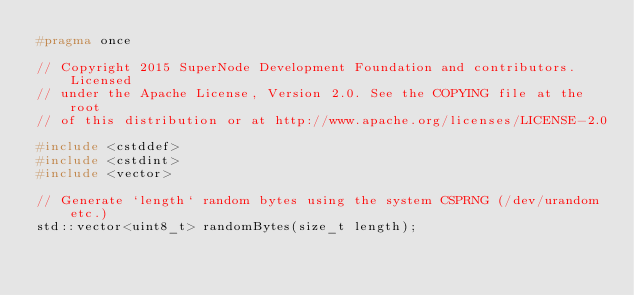<code> <loc_0><loc_0><loc_500><loc_500><_C_>#pragma once

// Copyright 2015 SuperNode Development Foundation and contributors. Licensed
// under the Apache License, Version 2.0. See the COPYING file at the root
// of this distribution or at http://www.apache.org/licenses/LICENSE-2.0

#include <cstddef>
#include <cstdint>
#include <vector>

// Generate `length` random bytes using the system CSPRNG (/dev/urandom etc.)
std::vector<uint8_t> randomBytes(size_t length);
</code> 